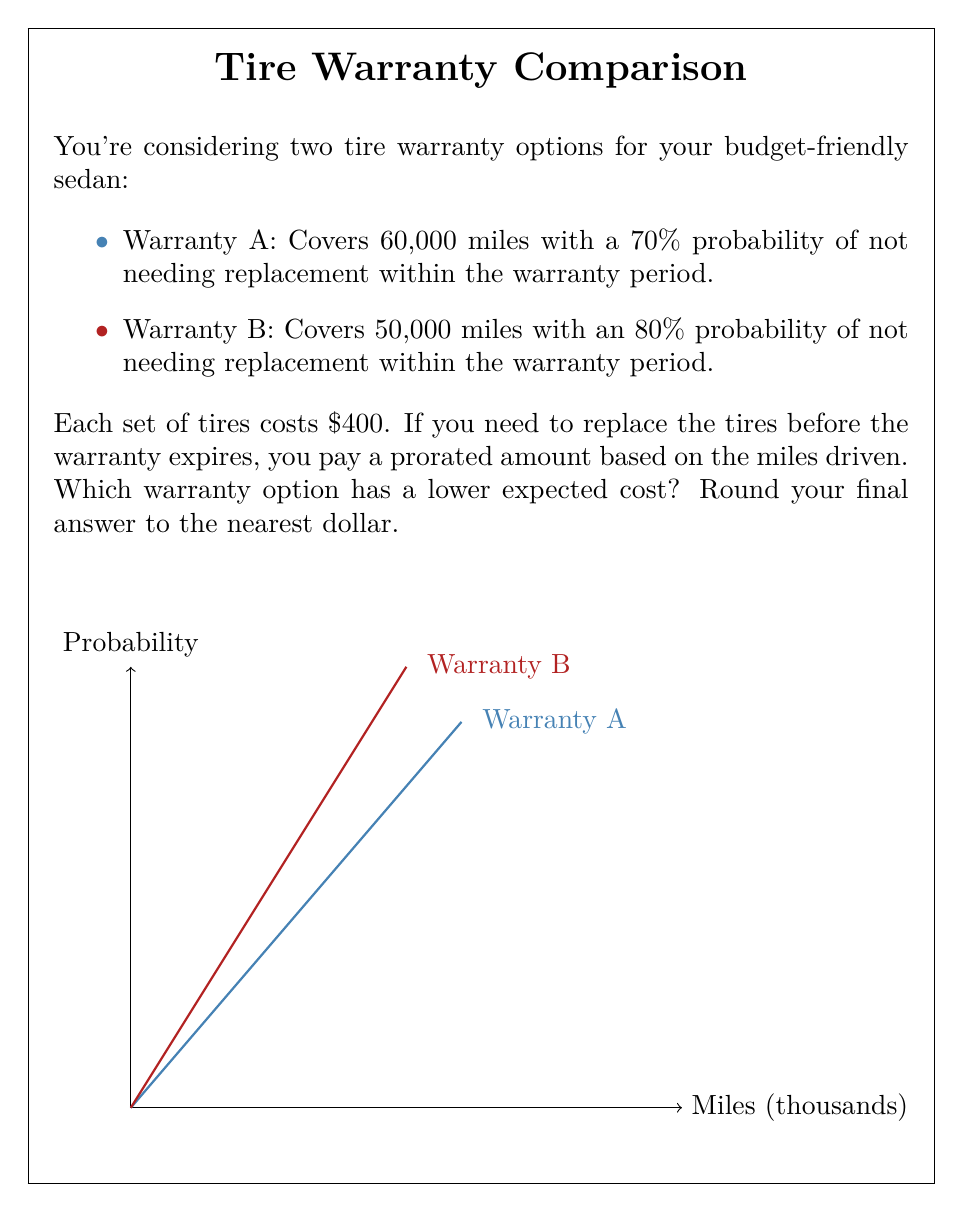Show me your answer to this math problem. Let's approach this step-by-step:

1) First, we need to calculate the expected cost for each warranty option.

2) For Warranty A:
   - Probability of not needing replacement: 70% = 0.7
   - Probability of needing replacement: 30% = 0.3
   - If replacement is needed, we assume on average it happens halfway through the warranty period (30,000 miles)
   - Prorated cost if replacement needed: $400 * (30,000 / 60,000) = $200

   Expected cost = $400 * 0.7 + ($400 + $200) * 0.3
                 = $280 + $180 = $460

3) For Warranty B:
   - Probability of not needing replacement: 80% = 0.8
   - Probability of needing replacement: 20% = 0.2
   - If replacement is needed, we assume on average it happens halfway through the warranty period (25,000 miles)
   - Prorated cost if replacement needed: $400 * (25,000 / 50,000) = $200

   Expected cost = $400 * 0.8 + ($400 + $200) * 0.2
                 = $320 + $120 = $440

4) Comparing the two:
   Warranty A expected cost: $460
   Warranty B expected cost: $440

5) The difference is $460 - $440 = $20 in favor of Warranty B.

Therefore, Warranty B has a lower expected cost by $20.
Answer: Warranty B, $440 